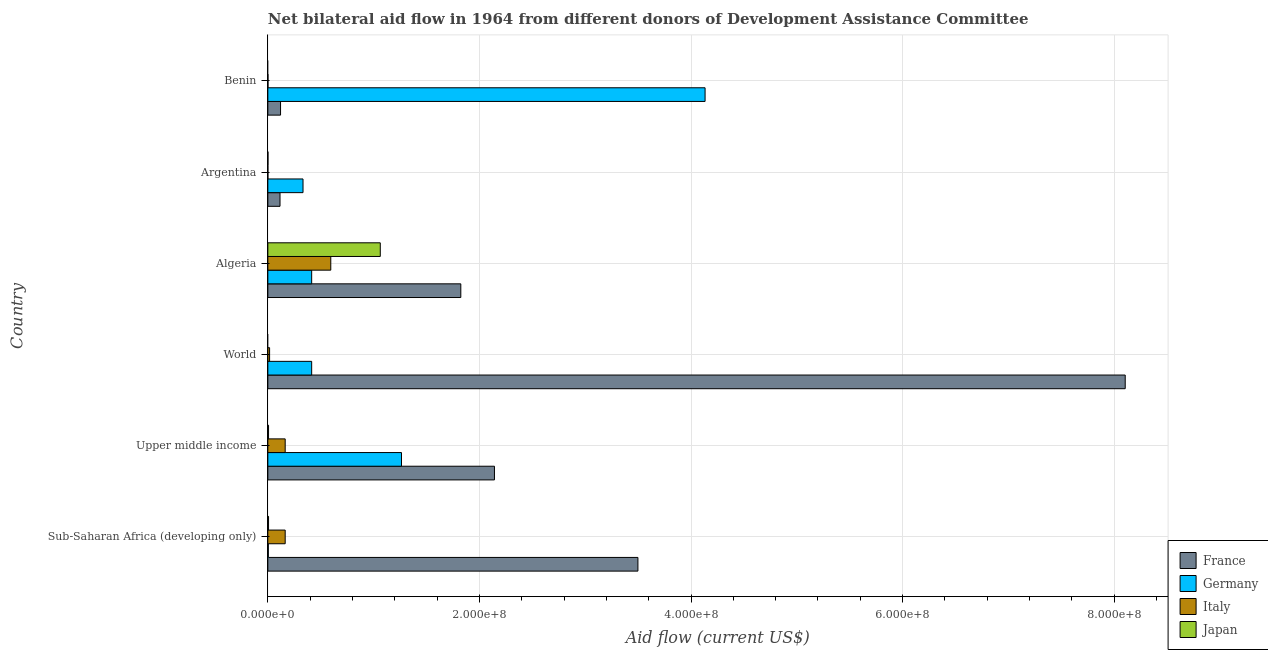How many groups of bars are there?
Ensure brevity in your answer.  6. Are the number of bars per tick equal to the number of legend labels?
Your answer should be compact. No. Are the number of bars on each tick of the Y-axis equal?
Offer a very short reply. No. How many bars are there on the 6th tick from the top?
Your response must be concise. 4. How many bars are there on the 2nd tick from the bottom?
Keep it short and to the point. 4. What is the label of the 6th group of bars from the top?
Ensure brevity in your answer.  Sub-Saharan Africa (developing only). What is the amount of aid given by japan in Algeria?
Give a very brief answer. 1.06e+08. Across all countries, what is the maximum amount of aid given by france?
Give a very brief answer. 8.10e+08. Across all countries, what is the minimum amount of aid given by italy?
Ensure brevity in your answer.  3.00e+04. In which country was the amount of aid given by japan maximum?
Provide a succinct answer. Algeria. What is the total amount of aid given by france in the graph?
Your response must be concise. 1.58e+09. What is the difference between the amount of aid given by germany in Argentina and that in World?
Give a very brief answer. -8.18e+06. What is the difference between the amount of aid given by germany in World and the amount of aid given by france in Sub-Saharan Africa (developing only)?
Your answer should be very brief. -3.08e+08. What is the average amount of aid given by italy per country?
Ensure brevity in your answer.  1.57e+07. What is the difference between the amount of aid given by germany and amount of aid given by japan in Upper middle income?
Ensure brevity in your answer.  1.26e+08. In how many countries, is the amount of aid given by germany greater than 720000000 US$?
Provide a succinct answer. 0. What is the ratio of the amount of aid given by japan in Algeria to that in Argentina?
Provide a short and direct response. 1062.8. Is the amount of aid given by france in Argentina less than that in World?
Your answer should be very brief. Yes. What is the difference between the highest and the second highest amount of aid given by japan?
Give a very brief answer. 1.06e+08. What is the difference between the highest and the lowest amount of aid given by italy?
Your answer should be compact. 5.95e+07. In how many countries, is the amount of aid given by italy greater than the average amount of aid given by italy taken over all countries?
Give a very brief answer. 3. Is it the case that in every country, the sum of the amount of aid given by france and amount of aid given by japan is greater than the sum of amount of aid given by germany and amount of aid given by italy?
Your response must be concise. No. Is it the case that in every country, the sum of the amount of aid given by france and amount of aid given by germany is greater than the amount of aid given by italy?
Your response must be concise. Yes. How many bars are there?
Your answer should be very brief. 22. What is the difference between two consecutive major ticks on the X-axis?
Provide a succinct answer. 2.00e+08. Are the values on the major ticks of X-axis written in scientific E-notation?
Offer a very short reply. Yes. Does the graph contain any zero values?
Provide a short and direct response. Yes. Where does the legend appear in the graph?
Your response must be concise. Bottom right. How many legend labels are there?
Offer a terse response. 4. What is the title of the graph?
Ensure brevity in your answer.  Net bilateral aid flow in 1964 from different donors of Development Assistance Committee. Does "Services" appear as one of the legend labels in the graph?
Give a very brief answer. No. What is the Aid flow (current US$) of France in Sub-Saharan Africa (developing only)?
Make the answer very short. 3.50e+08. What is the Aid flow (current US$) of Italy in Sub-Saharan Africa (developing only)?
Provide a succinct answer. 1.64e+07. What is the Aid flow (current US$) of Japan in Sub-Saharan Africa (developing only)?
Give a very brief answer. 6.60e+05. What is the Aid flow (current US$) in France in Upper middle income?
Your answer should be very brief. 2.14e+08. What is the Aid flow (current US$) in Germany in Upper middle income?
Offer a terse response. 1.26e+08. What is the Aid flow (current US$) of Italy in Upper middle income?
Provide a short and direct response. 1.64e+07. What is the Aid flow (current US$) of France in World?
Your answer should be compact. 8.10e+08. What is the Aid flow (current US$) of Germany in World?
Provide a short and direct response. 4.14e+07. What is the Aid flow (current US$) in Italy in World?
Keep it short and to the point. 1.66e+06. What is the Aid flow (current US$) of Japan in World?
Offer a very short reply. 0. What is the Aid flow (current US$) in France in Algeria?
Provide a short and direct response. 1.82e+08. What is the Aid flow (current US$) in Germany in Algeria?
Your response must be concise. 4.14e+07. What is the Aid flow (current US$) in Italy in Algeria?
Provide a short and direct response. 5.95e+07. What is the Aid flow (current US$) in Japan in Algeria?
Make the answer very short. 1.06e+08. What is the Aid flow (current US$) in France in Argentina?
Give a very brief answer. 1.15e+07. What is the Aid flow (current US$) in Germany in Argentina?
Your answer should be compact. 3.32e+07. What is the Aid flow (current US$) of Italy in Argentina?
Provide a succinct answer. 3.00e+04. What is the Aid flow (current US$) in Germany in Benin?
Provide a succinct answer. 4.13e+08. What is the Aid flow (current US$) of Italy in Benin?
Your answer should be compact. 1.30e+05. What is the Aid flow (current US$) in Japan in Benin?
Offer a very short reply. 0. Across all countries, what is the maximum Aid flow (current US$) of France?
Ensure brevity in your answer.  8.10e+08. Across all countries, what is the maximum Aid flow (current US$) in Germany?
Offer a very short reply. 4.13e+08. Across all countries, what is the maximum Aid flow (current US$) in Italy?
Offer a very short reply. 5.95e+07. Across all countries, what is the maximum Aid flow (current US$) in Japan?
Provide a short and direct response. 1.06e+08. Across all countries, what is the minimum Aid flow (current US$) of France?
Your answer should be compact. 1.15e+07. Across all countries, what is the minimum Aid flow (current US$) in Italy?
Keep it short and to the point. 3.00e+04. Across all countries, what is the minimum Aid flow (current US$) in Japan?
Offer a very short reply. 0. What is the total Aid flow (current US$) in France in the graph?
Make the answer very short. 1.58e+09. What is the total Aid flow (current US$) of Germany in the graph?
Your answer should be compact. 6.56e+08. What is the total Aid flow (current US$) in Italy in the graph?
Keep it short and to the point. 9.41e+07. What is the total Aid flow (current US$) of Japan in the graph?
Ensure brevity in your answer.  1.08e+08. What is the difference between the Aid flow (current US$) in France in Sub-Saharan Africa (developing only) and that in Upper middle income?
Offer a very short reply. 1.36e+08. What is the difference between the Aid flow (current US$) of Germany in Sub-Saharan Africa (developing only) and that in Upper middle income?
Provide a short and direct response. -1.26e+08. What is the difference between the Aid flow (current US$) in Japan in Sub-Saharan Africa (developing only) and that in Upper middle income?
Offer a terse response. 0. What is the difference between the Aid flow (current US$) of France in Sub-Saharan Africa (developing only) and that in World?
Provide a succinct answer. -4.61e+08. What is the difference between the Aid flow (current US$) in Germany in Sub-Saharan Africa (developing only) and that in World?
Your response must be concise. -4.10e+07. What is the difference between the Aid flow (current US$) in Italy in Sub-Saharan Africa (developing only) and that in World?
Ensure brevity in your answer.  1.47e+07. What is the difference between the Aid flow (current US$) of France in Sub-Saharan Africa (developing only) and that in Algeria?
Your answer should be compact. 1.67e+08. What is the difference between the Aid flow (current US$) in Germany in Sub-Saharan Africa (developing only) and that in Algeria?
Offer a very short reply. -4.10e+07. What is the difference between the Aid flow (current US$) of Italy in Sub-Saharan Africa (developing only) and that in Algeria?
Your response must be concise. -4.31e+07. What is the difference between the Aid flow (current US$) of Japan in Sub-Saharan Africa (developing only) and that in Algeria?
Offer a very short reply. -1.06e+08. What is the difference between the Aid flow (current US$) of France in Sub-Saharan Africa (developing only) and that in Argentina?
Your answer should be very brief. 3.38e+08. What is the difference between the Aid flow (current US$) of Germany in Sub-Saharan Africa (developing only) and that in Argentina?
Your answer should be compact. -3.28e+07. What is the difference between the Aid flow (current US$) of Italy in Sub-Saharan Africa (developing only) and that in Argentina?
Offer a very short reply. 1.64e+07. What is the difference between the Aid flow (current US$) in Japan in Sub-Saharan Africa (developing only) and that in Argentina?
Your response must be concise. 5.60e+05. What is the difference between the Aid flow (current US$) of France in Sub-Saharan Africa (developing only) and that in Benin?
Your answer should be compact. 3.38e+08. What is the difference between the Aid flow (current US$) in Germany in Sub-Saharan Africa (developing only) and that in Benin?
Your response must be concise. -4.13e+08. What is the difference between the Aid flow (current US$) of Italy in Sub-Saharan Africa (developing only) and that in Benin?
Offer a terse response. 1.63e+07. What is the difference between the Aid flow (current US$) of France in Upper middle income and that in World?
Your answer should be compact. -5.96e+08. What is the difference between the Aid flow (current US$) in Germany in Upper middle income and that in World?
Provide a succinct answer. 8.49e+07. What is the difference between the Aid flow (current US$) in Italy in Upper middle income and that in World?
Keep it short and to the point. 1.47e+07. What is the difference between the Aid flow (current US$) in France in Upper middle income and that in Algeria?
Provide a succinct answer. 3.18e+07. What is the difference between the Aid flow (current US$) of Germany in Upper middle income and that in Algeria?
Give a very brief answer. 8.49e+07. What is the difference between the Aid flow (current US$) in Italy in Upper middle income and that in Algeria?
Make the answer very short. -4.31e+07. What is the difference between the Aid flow (current US$) in Japan in Upper middle income and that in Algeria?
Your response must be concise. -1.06e+08. What is the difference between the Aid flow (current US$) in France in Upper middle income and that in Argentina?
Your answer should be very brief. 2.03e+08. What is the difference between the Aid flow (current US$) of Germany in Upper middle income and that in Argentina?
Ensure brevity in your answer.  9.31e+07. What is the difference between the Aid flow (current US$) of Italy in Upper middle income and that in Argentina?
Make the answer very short. 1.64e+07. What is the difference between the Aid flow (current US$) in Japan in Upper middle income and that in Argentina?
Keep it short and to the point. 5.60e+05. What is the difference between the Aid flow (current US$) of France in Upper middle income and that in Benin?
Ensure brevity in your answer.  2.02e+08. What is the difference between the Aid flow (current US$) in Germany in Upper middle income and that in Benin?
Your answer should be very brief. -2.87e+08. What is the difference between the Aid flow (current US$) of Italy in Upper middle income and that in Benin?
Your answer should be very brief. 1.63e+07. What is the difference between the Aid flow (current US$) in France in World and that in Algeria?
Your response must be concise. 6.28e+08. What is the difference between the Aid flow (current US$) of Italy in World and that in Algeria?
Provide a short and direct response. -5.78e+07. What is the difference between the Aid flow (current US$) in France in World and that in Argentina?
Give a very brief answer. 7.99e+08. What is the difference between the Aid flow (current US$) of Germany in World and that in Argentina?
Make the answer very short. 8.18e+06. What is the difference between the Aid flow (current US$) in Italy in World and that in Argentina?
Your answer should be very brief. 1.63e+06. What is the difference between the Aid flow (current US$) of France in World and that in Benin?
Provide a short and direct response. 7.98e+08. What is the difference between the Aid flow (current US$) in Germany in World and that in Benin?
Keep it short and to the point. -3.72e+08. What is the difference between the Aid flow (current US$) of Italy in World and that in Benin?
Give a very brief answer. 1.53e+06. What is the difference between the Aid flow (current US$) of France in Algeria and that in Argentina?
Keep it short and to the point. 1.71e+08. What is the difference between the Aid flow (current US$) in Germany in Algeria and that in Argentina?
Ensure brevity in your answer.  8.18e+06. What is the difference between the Aid flow (current US$) of Italy in Algeria and that in Argentina?
Ensure brevity in your answer.  5.95e+07. What is the difference between the Aid flow (current US$) of Japan in Algeria and that in Argentina?
Keep it short and to the point. 1.06e+08. What is the difference between the Aid flow (current US$) in France in Algeria and that in Benin?
Give a very brief answer. 1.70e+08. What is the difference between the Aid flow (current US$) in Germany in Algeria and that in Benin?
Make the answer very short. -3.72e+08. What is the difference between the Aid flow (current US$) of Italy in Algeria and that in Benin?
Provide a succinct answer. 5.94e+07. What is the difference between the Aid flow (current US$) in France in Argentina and that in Benin?
Your answer should be compact. -5.00e+05. What is the difference between the Aid flow (current US$) of Germany in Argentina and that in Benin?
Offer a terse response. -3.80e+08. What is the difference between the Aid flow (current US$) of France in Sub-Saharan Africa (developing only) and the Aid flow (current US$) of Germany in Upper middle income?
Ensure brevity in your answer.  2.23e+08. What is the difference between the Aid flow (current US$) in France in Sub-Saharan Africa (developing only) and the Aid flow (current US$) in Italy in Upper middle income?
Make the answer very short. 3.33e+08. What is the difference between the Aid flow (current US$) in France in Sub-Saharan Africa (developing only) and the Aid flow (current US$) in Japan in Upper middle income?
Offer a terse response. 3.49e+08. What is the difference between the Aid flow (current US$) in Germany in Sub-Saharan Africa (developing only) and the Aid flow (current US$) in Italy in Upper middle income?
Give a very brief answer. -1.59e+07. What is the difference between the Aid flow (current US$) of Germany in Sub-Saharan Africa (developing only) and the Aid flow (current US$) of Japan in Upper middle income?
Give a very brief answer. -2.00e+05. What is the difference between the Aid flow (current US$) in Italy in Sub-Saharan Africa (developing only) and the Aid flow (current US$) in Japan in Upper middle income?
Keep it short and to the point. 1.57e+07. What is the difference between the Aid flow (current US$) of France in Sub-Saharan Africa (developing only) and the Aid flow (current US$) of Germany in World?
Keep it short and to the point. 3.08e+08. What is the difference between the Aid flow (current US$) of France in Sub-Saharan Africa (developing only) and the Aid flow (current US$) of Italy in World?
Offer a very short reply. 3.48e+08. What is the difference between the Aid flow (current US$) in Germany in Sub-Saharan Africa (developing only) and the Aid flow (current US$) in Italy in World?
Provide a short and direct response. -1.20e+06. What is the difference between the Aid flow (current US$) in France in Sub-Saharan Africa (developing only) and the Aid flow (current US$) in Germany in Algeria?
Offer a very short reply. 3.08e+08. What is the difference between the Aid flow (current US$) of France in Sub-Saharan Africa (developing only) and the Aid flow (current US$) of Italy in Algeria?
Offer a very short reply. 2.90e+08. What is the difference between the Aid flow (current US$) in France in Sub-Saharan Africa (developing only) and the Aid flow (current US$) in Japan in Algeria?
Provide a short and direct response. 2.44e+08. What is the difference between the Aid flow (current US$) of Germany in Sub-Saharan Africa (developing only) and the Aid flow (current US$) of Italy in Algeria?
Make the answer very short. -5.90e+07. What is the difference between the Aid flow (current US$) of Germany in Sub-Saharan Africa (developing only) and the Aid flow (current US$) of Japan in Algeria?
Your response must be concise. -1.06e+08. What is the difference between the Aid flow (current US$) of Italy in Sub-Saharan Africa (developing only) and the Aid flow (current US$) of Japan in Algeria?
Ensure brevity in your answer.  -8.99e+07. What is the difference between the Aid flow (current US$) of France in Sub-Saharan Africa (developing only) and the Aid flow (current US$) of Germany in Argentina?
Offer a terse response. 3.17e+08. What is the difference between the Aid flow (current US$) in France in Sub-Saharan Africa (developing only) and the Aid flow (current US$) in Italy in Argentina?
Keep it short and to the point. 3.50e+08. What is the difference between the Aid flow (current US$) of France in Sub-Saharan Africa (developing only) and the Aid flow (current US$) of Japan in Argentina?
Provide a succinct answer. 3.50e+08. What is the difference between the Aid flow (current US$) of Germany in Sub-Saharan Africa (developing only) and the Aid flow (current US$) of Japan in Argentina?
Your answer should be very brief. 3.60e+05. What is the difference between the Aid flow (current US$) of Italy in Sub-Saharan Africa (developing only) and the Aid flow (current US$) of Japan in Argentina?
Your answer should be very brief. 1.63e+07. What is the difference between the Aid flow (current US$) of France in Sub-Saharan Africa (developing only) and the Aid flow (current US$) of Germany in Benin?
Provide a short and direct response. -6.35e+07. What is the difference between the Aid flow (current US$) in France in Sub-Saharan Africa (developing only) and the Aid flow (current US$) in Italy in Benin?
Keep it short and to the point. 3.50e+08. What is the difference between the Aid flow (current US$) in Germany in Sub-Saharan Africa (developing only) and the Aid flow (current US$) in Italy in Benin?
Make the answer very short. 3.30e+05. What is the difference between the Aid flow (current US$) of France in Upper middle income and the Aid flow (current US$) of Germany in World?
Provide a succinct answer. 1.73e+08. What is the difference between the Aid flow (current US$) in France in Upper middle income and the Aid flow (current US$) in Italy in World?
Provide a short and direct response. 2.13e+08. What is the difference between the Aid flow (current US$) of Germany in Upper middle income and the Aid flow (current US$) of Italy in World?
Give a very brief answer. 1.25e+08. What is the difference between the Aid flow (current US$) in France in Upper middle income and the Aid flow (current US$) in Germany in Algeria?
Make the answer very short. 1.73e+08. What is the difference between the Aid flow (current US$) of France in Upper middle income and the Aid flow (current US$) of Italy in Algeria?
Ensure brevity in your answer.  1.55e+08. What is the difference between the Aid flow (current US$) in France in Upper middle income and the Aid flow (current US$) in Japan in Algeria?
Provide a short and direct response. 1.08e+08. What is the difference between the Aid flow (current US$) in Germany in Upper middle income and the Aid flow (current US$) in Italy in Algeria?
Offer a terse response. 6.68e+07. What is the difference between the Aid flow (current US$) of Germany in Upper middle income and the Aid flow (current US$) of Japan in Algeria?
Your answer should be compact. 2.01e+07. What is the difference between the Aid flow (current US$) of Italy in Upper middle income and the Aid flow (current US$) of Japan in Algeria?
Ensure brevity in your answer.  -8.99e+07. What is the difference between the Aid flow (current US$) in France in Upper middle income and the Aid flow (current US$) in Germany in Argentina?
Your response must be concise. 1.81e+08. What is the difference between the Aid flow (current US$) of France in Upper middle income and the Aid flow (current US$) of Italy in Argentina?
Provide a succinct answer. 2.14e+08. What is the difference between the Aid flow (current US$) of France in Upper middle income and the Aid flow (current US$) of Japan in Argentina?
Your answer should be compact. 2.14e+08. What is the difference between the Aid flow (current US$) in Germany in Upper middle income and the Aid flow (current US$) in Italy in Argentina?
Give a very brief answer. 1.26e+08. What is the difference between the Aid flow (current US$) in Germany in Upper middle income and the Aid flow (current US$) in Japan in Argentina?
Offer a terse response. 1.26e+08. What is the difference between the Aid flow (current US$) in Italy in Upper middle income and the Aid flow (current US$) in Japan in Argentina?
Your answer should be very brief. 1.63e+07. What is the difference between the Aid flow (current US$) in France in Upper middle income and the Aid flow (current US$) in Germany in Benin?
Your response must be concise. -1.99e+08. What is the difference between the Aid flow (current US$) of France in Upper middle income and the Aid flow (current US$) of Italy in Benin?
Offer a very short reply. 2.14e+08. What is the difference between the Aid flow (current US$) in Germany in Upper middle income and the Aid flow (current US$) in Italy in Benin?
Offer a very short reply. 1.26e+08. What is the difference between the Aid flow (current US$) of France in World and the Aid flow (current US$) of Germany in Algeria?
Offer a terse response. 7.69e+08. What is the difference between the Aid flow (current US$) in France in World and the Aid flow (current US$) in Italy in Algeria?
Make the answer very short. 7.51e+08. What is the difference between the Aid flow (current US$) in France in World and the Aid flow (current US$) in Japan in Algeria?
Your answer should be very brief. 7.04e+08. What is the difference between the Aid flow (current US$) of Germany in World and the Aid flow (current US$) of Italy in Algeria?
Ensure brevity in your answer.  -1.81e+07. What is the difference between the Aid flow (current US$) in Germany in World and the Aid flow (current US$) in Japan in Algeria?
Offer a terse response. -6.48e+07. What is the difference between the Aid flow (current US$) of Italy in World and the Aid flow (current US$) of Japan in Algeria?
Keep it short and to the point. -1.05e+08. What is the difference between the Aid flow (current US$) of France in World and the Aid flow (current US$) of Germany in Argentina?
Offer a very short reply. 7.77e+08. What is the difference between the Aid flow (current US$) in France in World and the Aid flow (current US$) in Italy in Argentina?
Provide a short and direct response. 8.10e+08. What is the difference between the Aid flow (current US$) of France in World and the Aid flow (current US$) of Japan in Argentina?
Your answer should be very brief. 8.10e+08. What is the difference between the Aid flow (current US$) of Germany in World and the Aid flow (current US$) of Italy in Argentina?
Offer a terse response. 4.14e+07. What is the difference between the Aid flow (current US$) of Germany in World and the Aid flow (current US$) of Japan in Argentina?
Your response must be concise. 4.13e+07. What is the difference between the Aid flow (current US$) of Italy in World and the Aid flow (current US$) of Japan in Argentina?
Keep it short and to the point. 1.56e+06. What is the difference between the Aid flow (current US$) in France in World and the Aid flow (current US$) in Germany in Benin?
Provide a short and direct response. 3.97e+08. What is the difference between the Aid flow (current US$) of France in World and the Aid flow (current US$) of Italy in Benin?
Your answer should be compact. 8.10e+08. What is the difference between the Aid flow (current US$) in Germany in World and the Aid flow (current US$) in Italy in Benin?
Offer a terse response. 4.13e+07. What is the difference between the Aid flow (current US$) in France in Algeria and the Aid flow (current US$) in Germany in Argentina?
Keep it short and to the point. 1.49e+08. What is the difference between the Aid flow (current US$) of France in Algeria and the Aid flow (current US$) of Italy in Argentina?
Offer a very short reply. 1.82e+08. What is the difference between the Aid flow (current US$) in France in Algeria and the Aid flow (current US$) in Japan in Argentina?
Provide a short and direct response. 1.82e+08. What is the difference between the Aid flow (current US$) of Germany in Algeria and the Aid flow (current US$) of Italy in Argentina?
Offer a very short reply. 4.14e+07. What is the difference between the Aid flow (current US$) in Germany in Algeria and the Aid flow (current US$) in Japan in Argentina?
Your answer should be very brief. 4.13e+07. What is the difference between the Aid flow (current US$) of Italy in Algeria and the Aid flow (current US$) of Japan in Argentina?
Your answer should be very brief. 5.94e+07. What is the difference between the Aid flow (current US$) of France in Algeria and the Aid flow (current US$) of Germany in Benin?
Keep it short and to the point. -2.31e+08. What is the difference between the Aid flow (current US$) in France in Algeria and the Aid flow (current US$) in Italy in Benin?
Offer a terse response. 1.82e+08. What is the difference between the Aid flow (current US$) of Germany in Algeria and the Aid flow (current US$) of Italy in Benin?
Your answer should be compact. 4.13e+07. What is the difference between the Aid flow (current US$) of France in Argentina and the Aid flow (current US$) of Germany in Benin?
Offer a terse response. -4.02e+08. What is the difference between the Aid flow (current US$) in France in Argentina and the Aid flow (current US$) in Italy in Benin?
Offer a terse response. 1.14e+07. What is the difference between the Aid flow (current US$) of Germany in Argentina and the Aid flow (current US$) of Italy in Benin?
Your answer should be very brief. 3.31e+07. What is the average Aid flow (current US$) in France per country?
Give a very brief answer. 2.63e+08. What is the average Aid flow (current US$) in Germany per country?
Your response must be concise. 1.09e+08. What is the average Aid flow (current US$) of Italy per country?
Your response must be concise. 1.57e+07. What is the average Aid flow (current US$) of Japan per country?
Give a very brief answer. 1.80e+07. What is the difference between the Aid flow (current US$) in France and Aid flow (current US$) in Germany in Sub-Saharan Africa (developing only)?
Offer a terse response. 3.49e+08. What is the difference between the Aid flow (current US$) of France and Aid flow (current US$) of Italy in Sub-Saharan Africa (developing only)?
Make the answer very short. 3.33e+08. What is the difference between the Aid flow (current US$) in France and Aid flow (current US$) in Japan in Sub-Saharan Africa (developing only)?
Offer a very short reply. 3.49e+08. What is the difference between the Aid flow (current US$) in Germany and Aid flow (current US$) in Italy in Sub-Saharan Africa (developing only)?
Your answer should be compact. -1.59e+07. What is the difference between the Aid flow (current US$) in Germany and Aid flow (current US$) in Japan in Sub-Saharan Africa (developing only)?
Your answer should be compact. -2.00e+05. What is the difference between the Aid flow (current US$) of Italy and Aid flow (current US$) of Japan in Sub-Saharan Africa (developing only)?
Your response must be concise. 1.57e+07. What is the difference between the Aid flow (current US$) of France and Aid flow (current US$) of Germany in Upper middle income?
Provide a short and direct response. 8.79e+07. What is the difference between the Aid flow (current US$) in France and Aid flow (current US$) in Italy in Upper middle income?
Make the answer very short. 1.98e+08. What is the difference between the Aid flow (current US$) in France and Aid flow (current US$) in Japan in Upper middle income?
Your answer should be compact. 2.14e+08. What is the difference between the Aid flow (current US$) of Germany and Aid flow (current US$) of Italy in Upper middle income?
Give a very brief answer. 1.10e+08. What is the difference between the Aid flow (current US$) of Germany and Aid flow (current US$) of Japan in Upper middle income?
Ensure brevity in your answer.  1.26e+08. What is the difference between the Aid flow (current US$) in Italy and Aid flow (current US$) in Japan in Upper middle income?
Your answer should be very brief. 1.57e+07. What is the difference between the Aid flow (current US$) of France and Aid flow (current US$) of Germany in World?
Offer a very short reply. 7.69e+08. What is the difference between the Aid flow (current US$) of France and Aid flow (current US$) of Italy in World?
Keep it short and to the point. 8.09e+08. What is the difference between the Aid flow (current US$) of Germany and Aid flow (current US$) of Italy in World?
Offer a very short reply. 3.98e+07. What is the difference between the Aid flow (current US$) in France and Aid flow (current US$) in Germany in Algeria?
Offer a terse response. 1.41e+08. What is the difference between the Aid flow (current US$) of France and Aid flow (current US$) of Italy in Algeria?
Your response must be concise. 1.23e+08. What is the difference between the Aid flow (current US$) in France and Aid flow (current US$) in Japan in Algeria?
Offer a very short reply. 7.61e+07. What is the difference between the Aid flow (current US$) of Germany and Aid flow (current US$) of Italy in Algeria?
Give a very brief answer. -1.81e+07. What is the difference between the Aid flow (current US$) in Germany and Aid flow (current US$) in Japan in Algeria?
Give a very brief answer. -6.48e+07. What is the difference between the Aid flow (current US$) of Italy and Aid flow (current US$) of Japan in Algeria?
Provide a succinct answer. -4.68e+07. What is the difference between the Aid flow (current US$) in France and Aid flow (current US$) in Germany in Argentina?
Keep it short and to the point. -2.18e+07. What is the difference between the Aid flow (current US$) of France and Aid flow (current US$) of Italy in Argentina?
Your answer should be very brief. 1.15e+07. What is the difference between the Aid flow (current US$) of France and Aid flow (current US$) of Japan in Argentina?
Ensure brevity in your answer.  1.14e+07. What is the difference between the Aid flow (current US$) in Germany and Aid flow (current US$) in Italy in Argentina?
Provide a short and direct response. 3.32e+07. What is the difference between the Aid flow (current US$) of Germany and Aid flow (current US$) of Japan in Argentina?
Offer a very short reply. 3.32e+07. What is the difference between the Aid flow (current US$) of Italy and Aid flow (current US$) of Japan in Argentina?
Keep it short and to the point. -7.00e+04. What is the difference between the Aid flow (current US$) of France and Aid flow (current US$) of Germany in Benin?
Offer a terse response. -4.01e+08. What is the difference between the Aid flow (current US$) in France and Aid flow (current US$) in Italy in Benin?
Your answer should be compact. 1.19e+07. What is the difference between the Aid flow (current US$) in Germany and Aid flow (current US$) in Italy in Benin?
Offer a terse response. 4.13e+08. What is the ratio of the Aid flow (current US$) in France in Sub-Saharan Africa (developing only) to that in Upper middle income?
Your response must be concise. 1.63. What is the ratio of the Aid flow (current US$) of Germany in Sub-Saharan Africa (developing only) to that in Upper middle income?
Provide a short and direct response. 0. What is the ratio of the Aid flow (current US$) in Japan in Sub-Saharan Africa (developing only) to that in Upper middle income?
Your answer should be very brief. 1. What is the ratio of the Aid flow (current US$) of France in Sub-Saharan Africa (developing only) to that in World?
Keep it short and to the point. 0.43. What is the ratio of the Aid flow (current US$) of Germany in Sub-Saharan Africa (developing only) to that in World?
Your answer should be compact. 0.01. What is the ratio of the Aid flow (current US$) of Italy in Sub-Saharan Africa (developing only) to that in World?
Your response must be concise. 9.88. What is the ratio of the Aid flow (current US$) in France in Sub-Saharan Africa (developing only) to that in Algeria?
Your answer should be very brief. 1.92. What is the ratio of the Aid flow (current US$) of Germany in Sub-Saharan Africa (developing only) to that in Algeria?
Provide a short and direct response. 0.01. What is the ratio of the Aid flow (current US$) of Italy in Sub-Saharan Africa (developing only) to that in Algeria?
Make the answer very short. 0.28. What is the ratio of the Aid flow (current US$) of Japan in Sub-Saharan Africa (developing only) to that in Algeria?
Offer a terse response. 0.01. What is the ratio of the Aid flow (current US$) in France in Sub-Saharan Africa (developing only) to that in Argentina?
Offer a terse response. 30.42. What is the ratio of the Aid flow (current US$) of Germany in Sub-Saharan Africa (developing only) to that in Argentina?
Your response must be concise. 0.01. What is the ratio of the Aid flow (current US$) of Italy in Sub-Saharan Africa (developing only) to that in Argentina?
Your answer should be compact. 546.67. What is the ratio of the Aid flow (current US$) of France in Sub-Saharan Africa (developing only) to that in Benin?
Your answer should be compact. 29.15. What is the ratio of the Aid flow (current US$) of Germany in Sub-Saharan Africa (developing only) to that in Benin?
Ensure brevity in your answer.  0. What is the ratio of the Aid flow (current US$) of Italy in Sub-Saharan Africa (developing only) to that in Benin?
Give a very brief answer. 126.15. What is the ratio of the Aid flow (current US$) of France in Upper middle income to that in World?
Your answer should be very brief. 0.26. What is the ratio of the Aid flow (current US$) of Germany in Upper middle income to that in World?
Your answer should be very brief. 3.05. What is the ratio of the Aid flow (current US$) of Italy in Upper middle income to that in World?
Offer a terse response. 9.88. What is the ratio of the Aid flow (current US$) in France in Upper middle income to that in Algeria?
Make the answer very short. 1.17. What is the ratio of the Aid flow (current US$) of Germany in Upper middle income to that in Algeria?
Give a very brief answer. 3.05. What is the ratio of the Aid flow (current US$) of Italy in Upper middle income to that in Algeria?
Provide a succinct answer. 0.28. What is the ratio of the Aid flow (current US$) of Japan in Upper middle income to that in Algeria?
Keep it short and to the point. 0.01. What is the ratio of the Aid flow (current US$) of France in Upper middle income to that in Argentina?
Your answer should be compact. 18.63. What is the ratio of the Aid flow (current US$) in Germany in Upper middle income to that in Argentina?
Your answer should be compact. 3.8. What is the ratio of the Aid flow (current US$) of Italy in Upper middle income to that in Argentina?
Give a very brief answer. 546.67. What is the ratio of the Aid flow (current US$) of France in Upper middle income to that in Benin?
Offer a terse response. 17.85. What is the ratio of the Aid flow (current US$) in Germany in Upper middle income to that in Benin?
Your response must be concise. 0.31. What is the ratio of the Aid flow (current US$) in Italy in Upper middle income to that in Benin?
Offer a very short reply. 126.15. What is the ratio of the Aid flow (current US$) of France in World to that in Algeria?
Provide a succinct answer. 4.44. What is the ratio of the Aid flow (current US$) in Germany in World to that in Algeria?
Provide a short and direct response. 1. What is the ratio of the Aid flow (current US$) in Italy in World to that in Algeria?
Ensure brevity in your answer.  0.03. What is the ratio of the Aid flow (current US$) in France in World to that in Argentina?
Give a very brief answer. 70.47. What is the ratio of the Aid flow (current US$) of Germany in World to that in Argentina?
Your answer should be compact. 1.25. What is the ratio of the Aid flow (current US$) of Italy in World to that in Argentina?
Offer a terse response. 55.33. What is the ratio of the Aid flow (current US$) of France in World to that in Benin?
Make the answer very short. 67.53. What is the ratio of the Aid flow (current US$) of Germany in World to that in Benin?
Offer a terse response. 0.1. What is the ratio of the Aid flow (current US$) in Italy in World to that in Benin?
Make the answer very short. 12.77. What is the ratio of the Aid flow (current US$) in France in Algeria to that in Argentina?
Keep it short and to the point. 15.86. What is the ratio of the Aid flow (current US$) in Germany in Algeria to that in Argentina?
Make the answer very short. 1.25. What is the ratio of the Aid flow (current US$) of Italy in Algeria to that in Argentina?
Your answer should be very brief. 1983. What is the ratio of the Aid flow (current US$) of Japan in Algeria to that in Argentina?
Keep it short and to the point. 1062.8. What is the ratio of the Aid flow (current US$) in Germany in Algeria to that in Benin?
Provide a short and direct response. 0.1. What is the ratio of the Aid flow (current US$) of Italy in Algeria to that in Benin?
Your response must be concise. 457.62. What is the ratio of the Aid flow (current US$) of France in Argentina to that in Benin?
Your response must be concise. 0.96. What is the ratio of the Aid flow (current US$) in Germany in Argentina to that in Benin?
Offer a very short reply. 0.08. What is the ratio of the Aid flow (current US$) of Italy in Argentina to that in Benin?
Offer a terse response. 0.23. What is the difference between the highest and the second highest Aid flow (current US$) in France?
Offer a very short reply. 4.61e+08. What is the difference between the highest and the second highest Aid flow (current US$) of Germany?
Make the answer very short. 2.87e+08. What is the difference between the highest and the second highest Aid flow (current US$) of Italy?
Your answer should be compact. 4.31e+07. What is the difference between the highest and the second highest Aid flow (current US$) in Japan?
Keep it short and to the point. 1.06e+08. What is the difference between the highest and the lowest Aid flow (current US$) of France?
Give a very brief answer. 7.99e+08. What is the difference between the highest and the lowest Aid flow (current US$) in Germany?
Make the answer very short. 4.13e+08. What is the difference between the highest and the lowest Aid flow (current US$) of Italy?
Make the answer very short. 5.95e+07. What is the difference between the highest and the lowest Aid flow (current US$) of Japan?
Your answer should be very brief. 1.06e+08. 